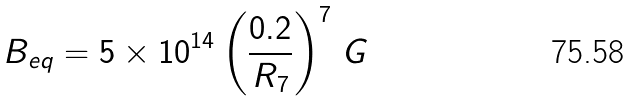<formula> <loc_0><loc_0><loc_500><loc_500>B _ { e q } = 5 \times 1 0 ^ { 1 4 } \left ( \frac { 0 . 2 } { R _ { 7 } } \right ) ^ { 7 } \, G</formula> 